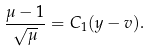<formula> <loc_0><loc_0><loc_500><loc_500>\frac { \mu - 1 } { \sqrt { \mu } } = C _ { 1 } ( y - v ) .</formula> 